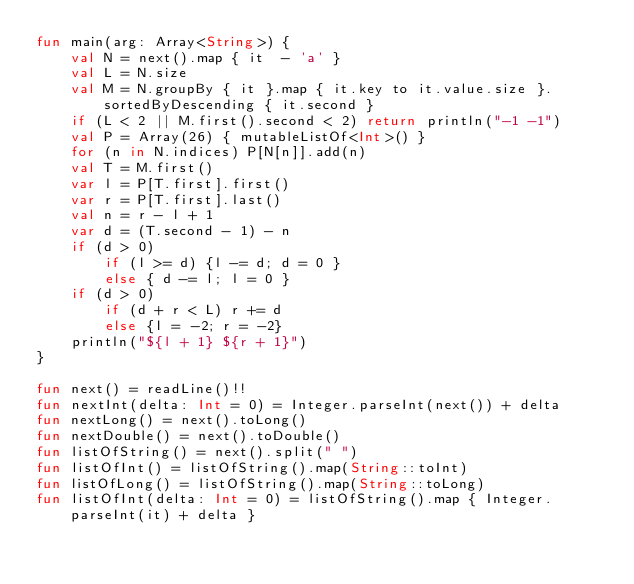Convert code to text. <code><loc_0><loc_0><loc_500><loc_500><_Kotlin_>fun main(arg: Array<String>) {
    val N = next().map { it  - 'a' }
    val L = N.size
    val M = N.groupBy { it }.map { it.key to it.value.size }.sortedByDescending { it.second }
    if (L < 2 || M.first().second < 2) return println("-1 -1")
    val P = Array(26) { mutableListOf<Int>() }
    for (n in N.indices) P[N[n]].add(n)
    val T = M.first()
    var l = P[T.first].first()
    var r = P[T.first].last()
    val n = r - l + 1
    var d = (T.second - 1) - n
    if (d > 0)
        if (l >= d) {l -= d; d = 0 }
        else { d -= l; l = 0 }
    if (d > 0)
        if (d + r < L) r += d
        else {l = -2; r = -2}
    println("${l + 1} ${r + 1}")
}

fun next() = readLine()!!
fun nextInt(delta: Int = 0) = Integer.parseInt(next()) + delta
fun nextLong() = next().toLong()
fun nextDouble() = next().toDouble()
fun listOfString() = next().split(" ")
fun listOfInt() = listOfString().map(String::toInt)
fun listOfLong() = listOfString().map(String::toLong)
fun listOfInt(delta: Int = 0) = listOfString().map { Integer.parseInt(it) + delta }

</code> 